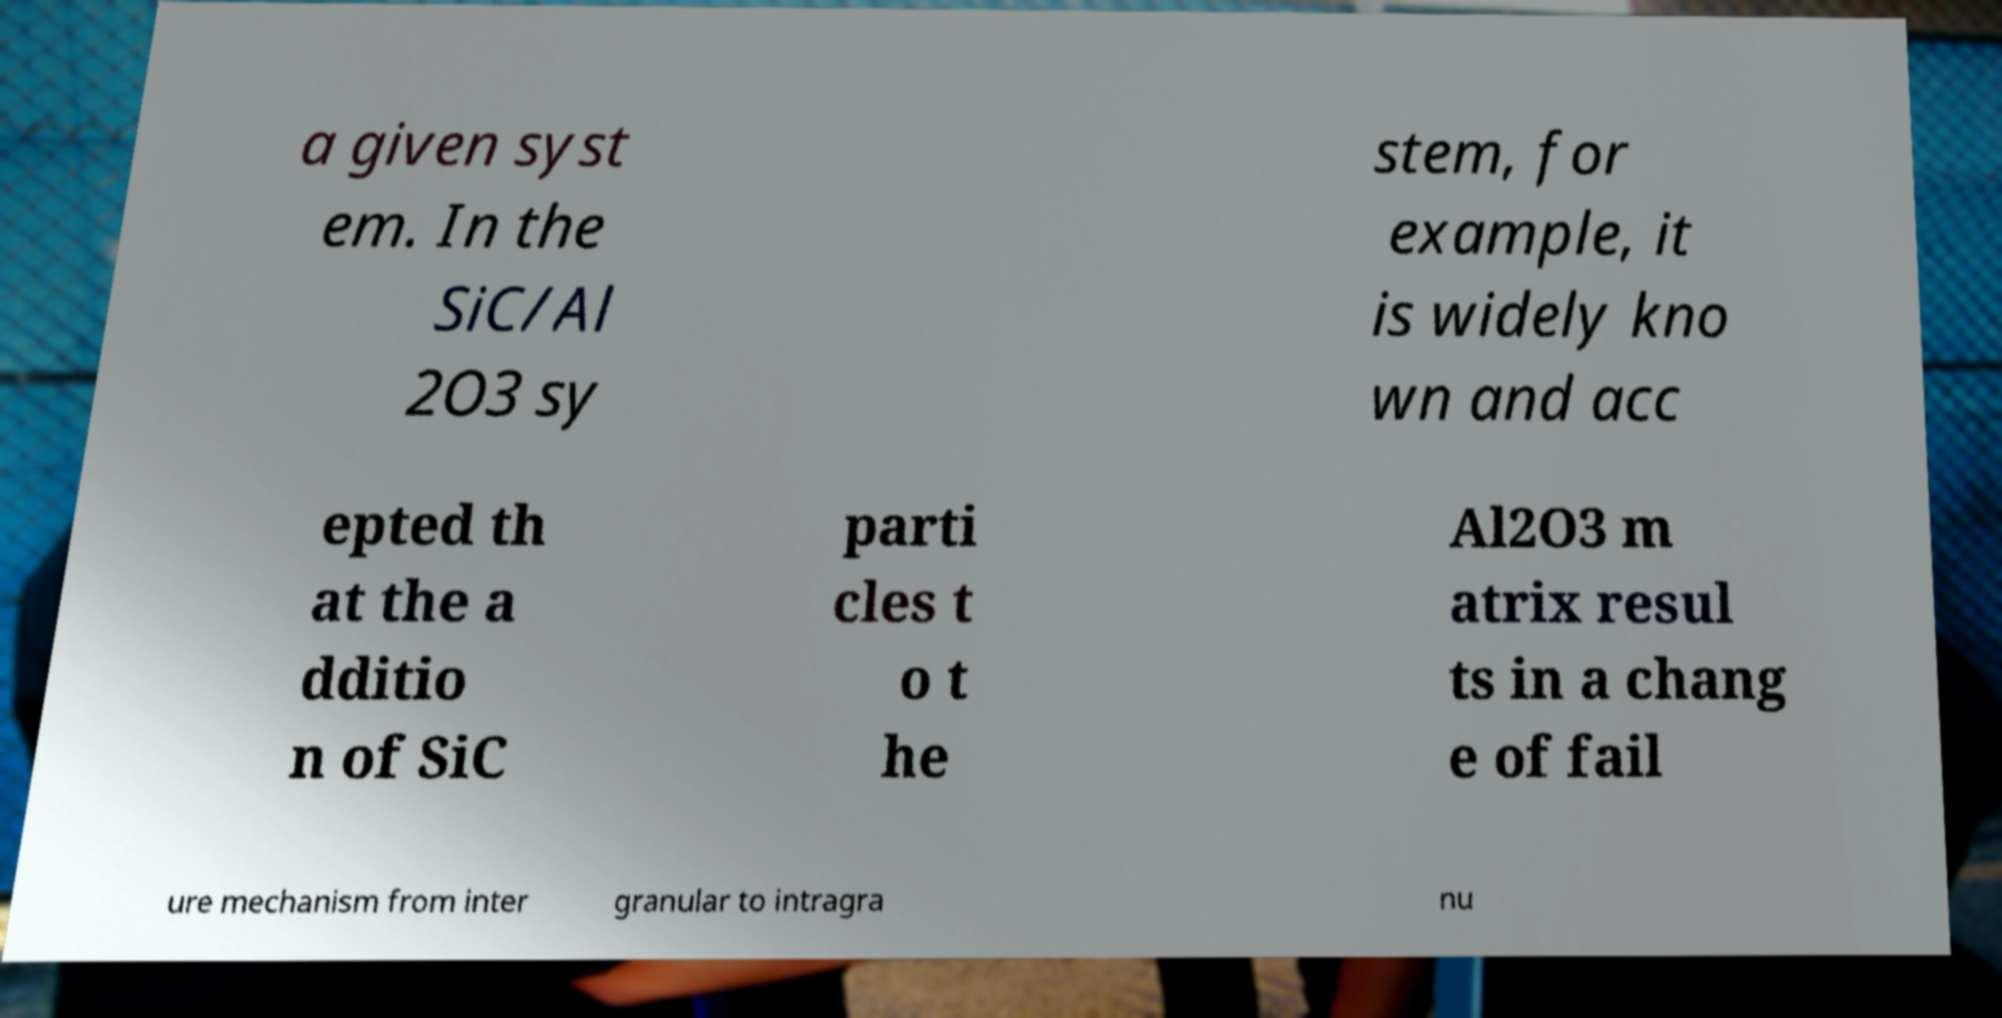Can you read and provide the text displayed in the image?This photo seems to have some interesting text. Can you extract and type it out for me? a given syst em. In the SiC/Al 2O3 sy stem, for example, it is widely kno wn and acc epted th at the a dditio n of SiC parti cles t o t he Al2O3 m atrix resul ts in a chang e of fail ure mechanism from inter granular to intragra nu 